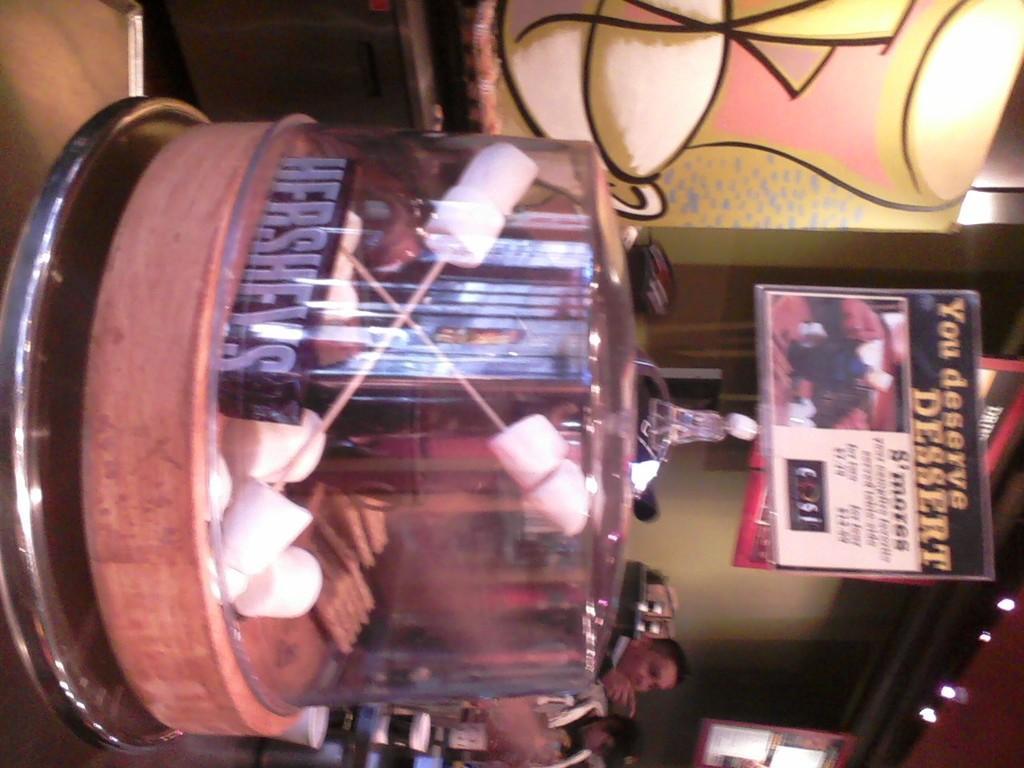How would you summarize this image in a sentence or two? In this image I can see the bowl with some marshmallows. To the side I can see few people and I can also see the boards and light in the top. In the background there is a an object which is in yellow, white and pink color. 